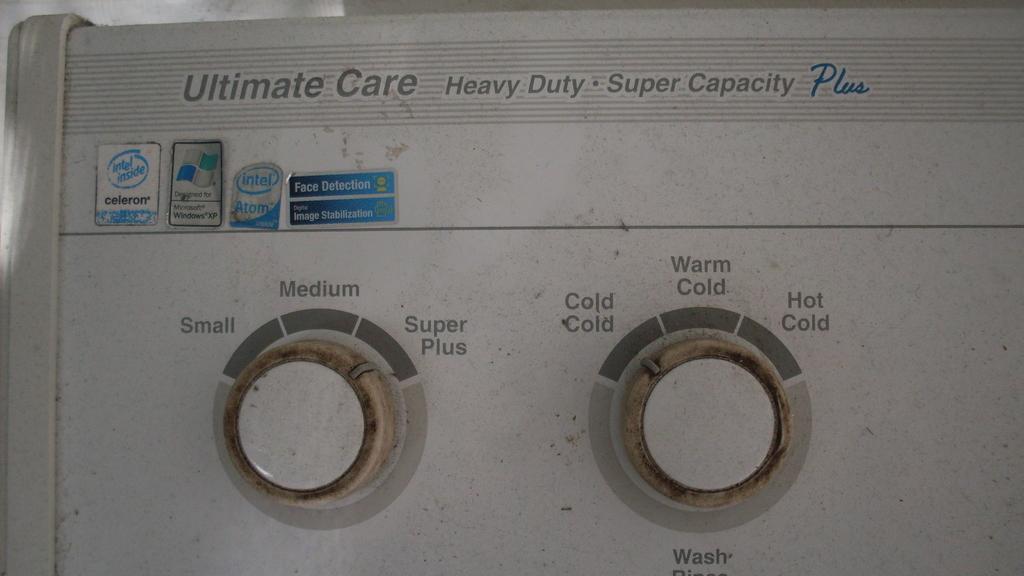Can you describe this image briefly? In this image we can see buttons and some text. 